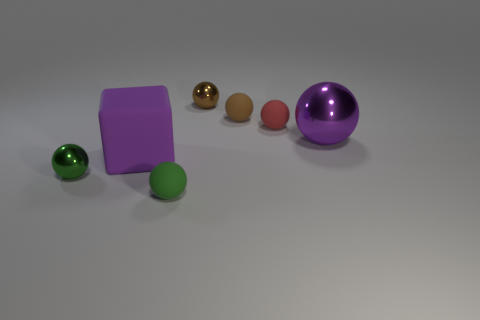What number of rubber things are either yellow cylinders or small brown objects?
Offer a terse response. 1. What is the size of the red rubber object?
Offer a very short reply. Small. How many things are tiny rubber things or matte cubes that are behind the green shiny sphere?
Make the answer very short. 4. What number of other things are there of the same color as the large rubber object?
Offer a very short reply. 1. There is a green shiny object; does it have the same size as the purple thing that is to the left of the brown matte thing?
Keep it short and to the point. No. There is a brown metal object behind the green matte sphere; does it have the same size as the red sphere?
Give a very brief answer. Yes. How many other objects are there of the same material as the large purple block?
Provide a short and direct response. 3. Are there an equal number of tiny matte objects behind the green matte ball and tiny green objects to the right of the red matte object?
Ensure brevity in your answer.  No. There is a big thing that is left of the sphere that is in front of the tiny green sphere that is behind the green matte object; what color is it?
Ensure brevity in your answer.  Purple. What is the shape of the tiny rubber thing in front of the big purple rubber object?
Ensure brevity in your answer.  Sphere. 